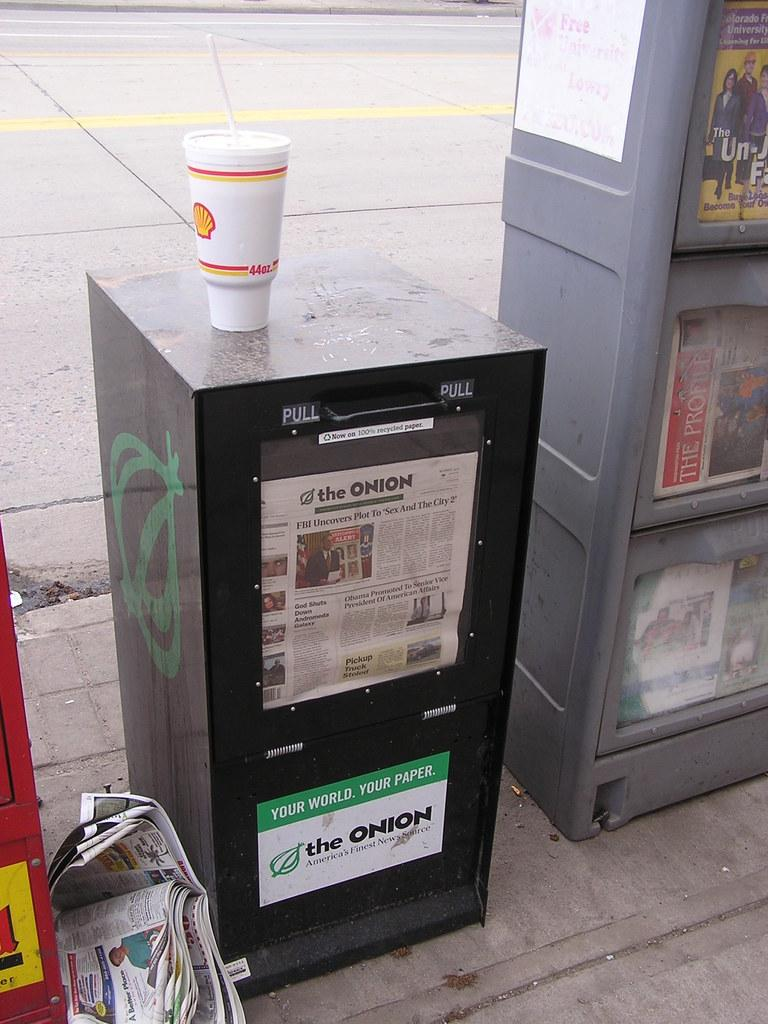What is in the glass that is visible in the image? There is a glass with a straw in the image. What type of furniture is present in the image? There are cupboards on the ground in the image. What can be seen besides the cupboards in the image? There is a book and posters in the image. What is visible in the background of the image? There is a road visible in the background of the image. How do the giants interact with the book in the image? There are no giants present in the image; it only features a book, cupboards, posters, a glass with a straw, and a road visible in the background. 